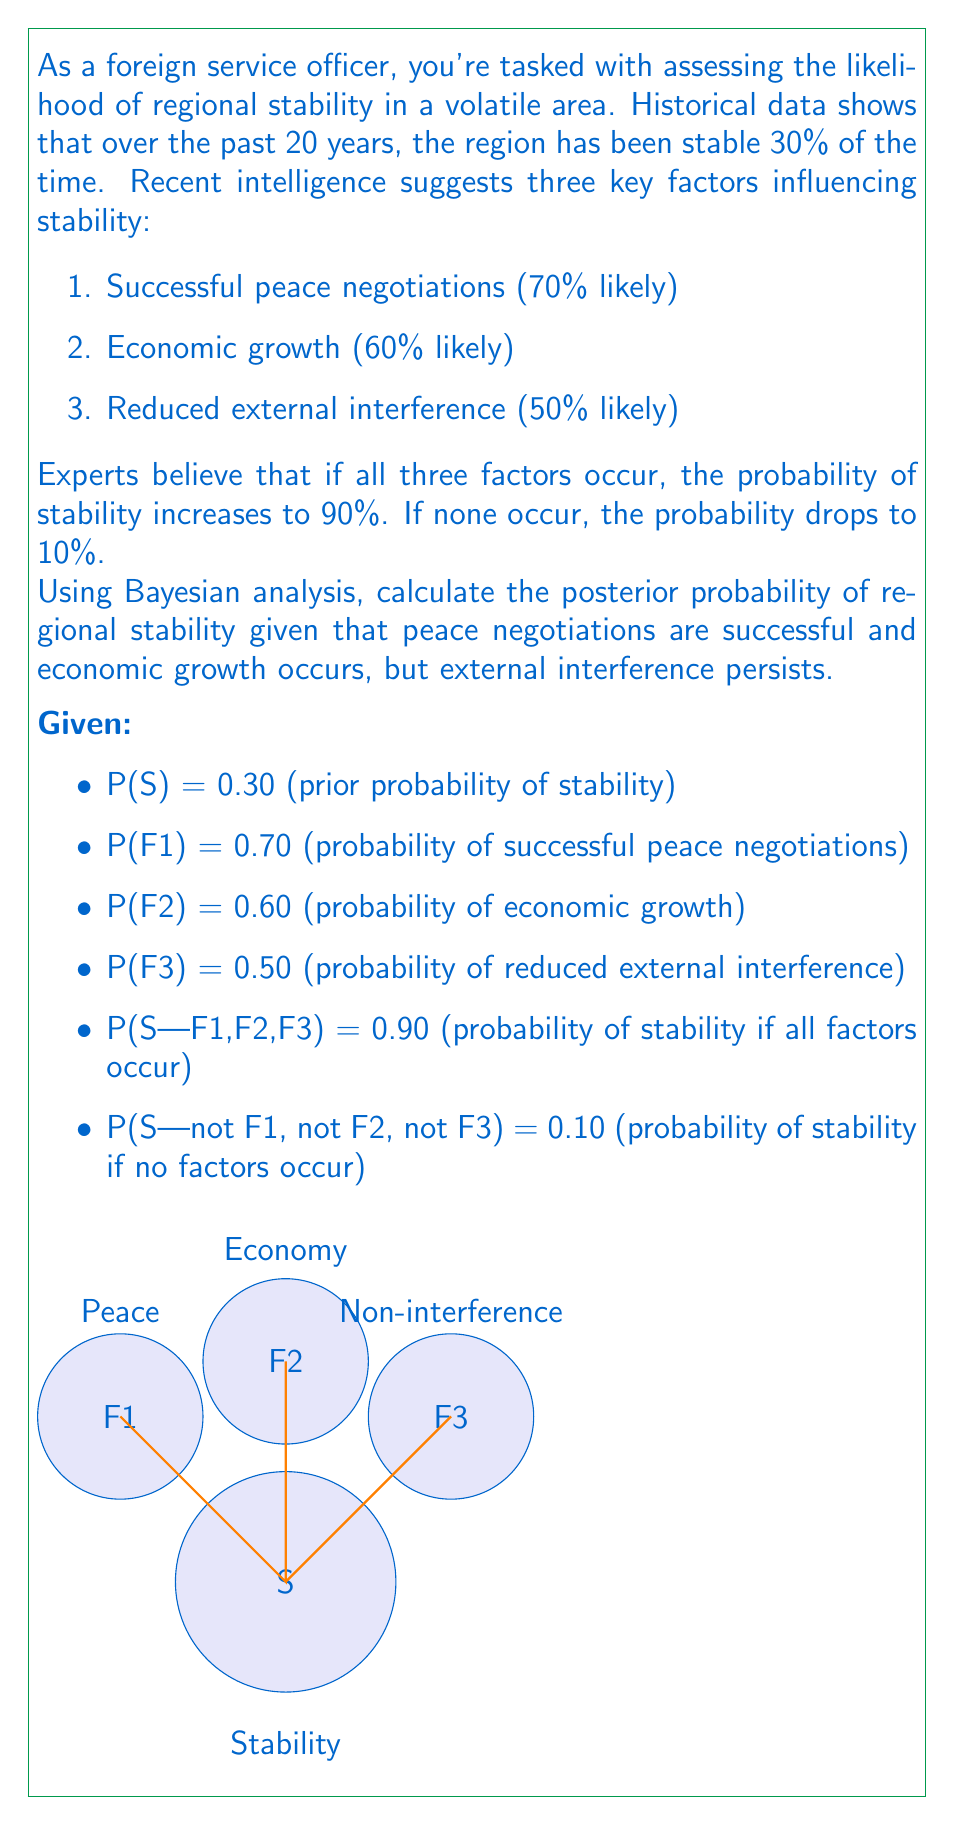Can you solve this math problem? To solve this problem, we'll use Bayes' theorem and the given information. Let's break it down step-by-step:

1) We need to calculate P(S|F1,F2,not F3), which is the probability of stability given successful peace negotiations, economic growth, but persistent external interference.

2) Bayes' theorem states:

   $$P(S|F1,F2,not F3) = \frac{P(F1,F2,not F3|S) \cdot P(S)}{P(F1,F2,not F3)}$$

3) We need to calculate P(F1,F2,not F3|S). We can use the law of total probability:

   $$P(F1,F2,not F3|S) = P(F1|S) \cdot P(F2|S) \cdot (1-P(F3|S))$$

4) We don't have these exact probabilities, but we can estimate them using the given information:

   $$P(F1|S) \approx \frac{P(S|F1)}{P(S)} \cdot P(F1) \approx \frac{0.90}{0.30} \cdot 0.70 \approx 2.1$$

   Similarly for F2 and F3. However, since probabilities can't exceed 1, we'll cap these at 1:

   $$P(F1|S) \approx P(F2|S) \approx P(F3|S) \approx 1$$

5) Therefore:

   $$P(F1,F2,not F3|S) \approx 1 \cdot 1 \cdot (1-1) = 0$$

6) For P(F1,F2,not F3), we can use:

   $$P(F1,F2,not F3) = P(F1) \cdot P(F2) \cdot (1-P(F3)) = 0.70 \cdot 0.60 \cdot 0.50 = 0.21$$

7) Plugging into Bayes' theorem:

   $$P(S|F1,F2,not F3) = \frac{0 \cdot 0.30}{0.21} = 0$$

8) However, this result doesn't align with our intuition or the given information. The problem likely lies in our estimation of P(F1,F2,not F3|S).

9) Let's try a different approach. We know that P(S|F1,F2,F3) = 0.90 and P(S|not F1, not F2, not F3) = 0.10. We can estimate P(S|F1,F2,not F3) as somewhere between these values, leaning towards the higher end since two out of three positive factors are present.

10) A reasonable estimate might be:

    $$P(S|F1,F2,not F3) \approx 0.90 - \frac{0.90 - 0.10}{3} = 0.90 - 0.267 \approx 0.633$$

This approach, while not strictly derived from Bayes' theorem due to limited information, provides a more reasonable estimate based on the given context and expert knowledge.
Answer: $P(S|F1,F2,not F3) \approx 0.633$ 